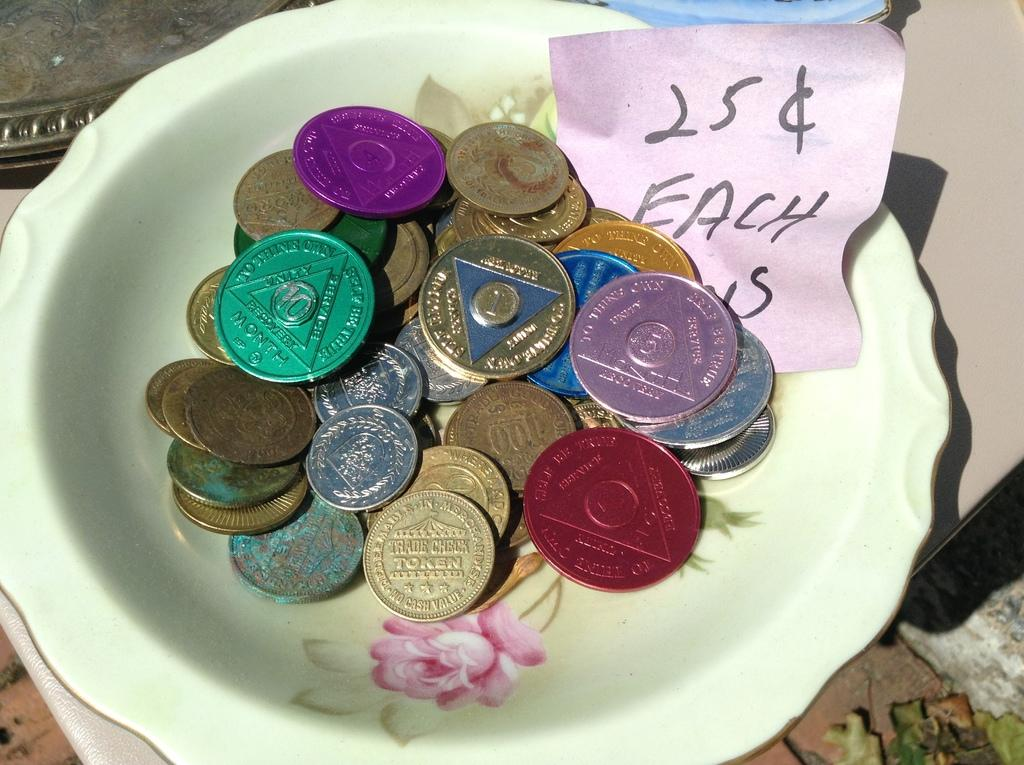<image>
Describe the image concisely. a bowl full of coins with a note that says 25 cents each 